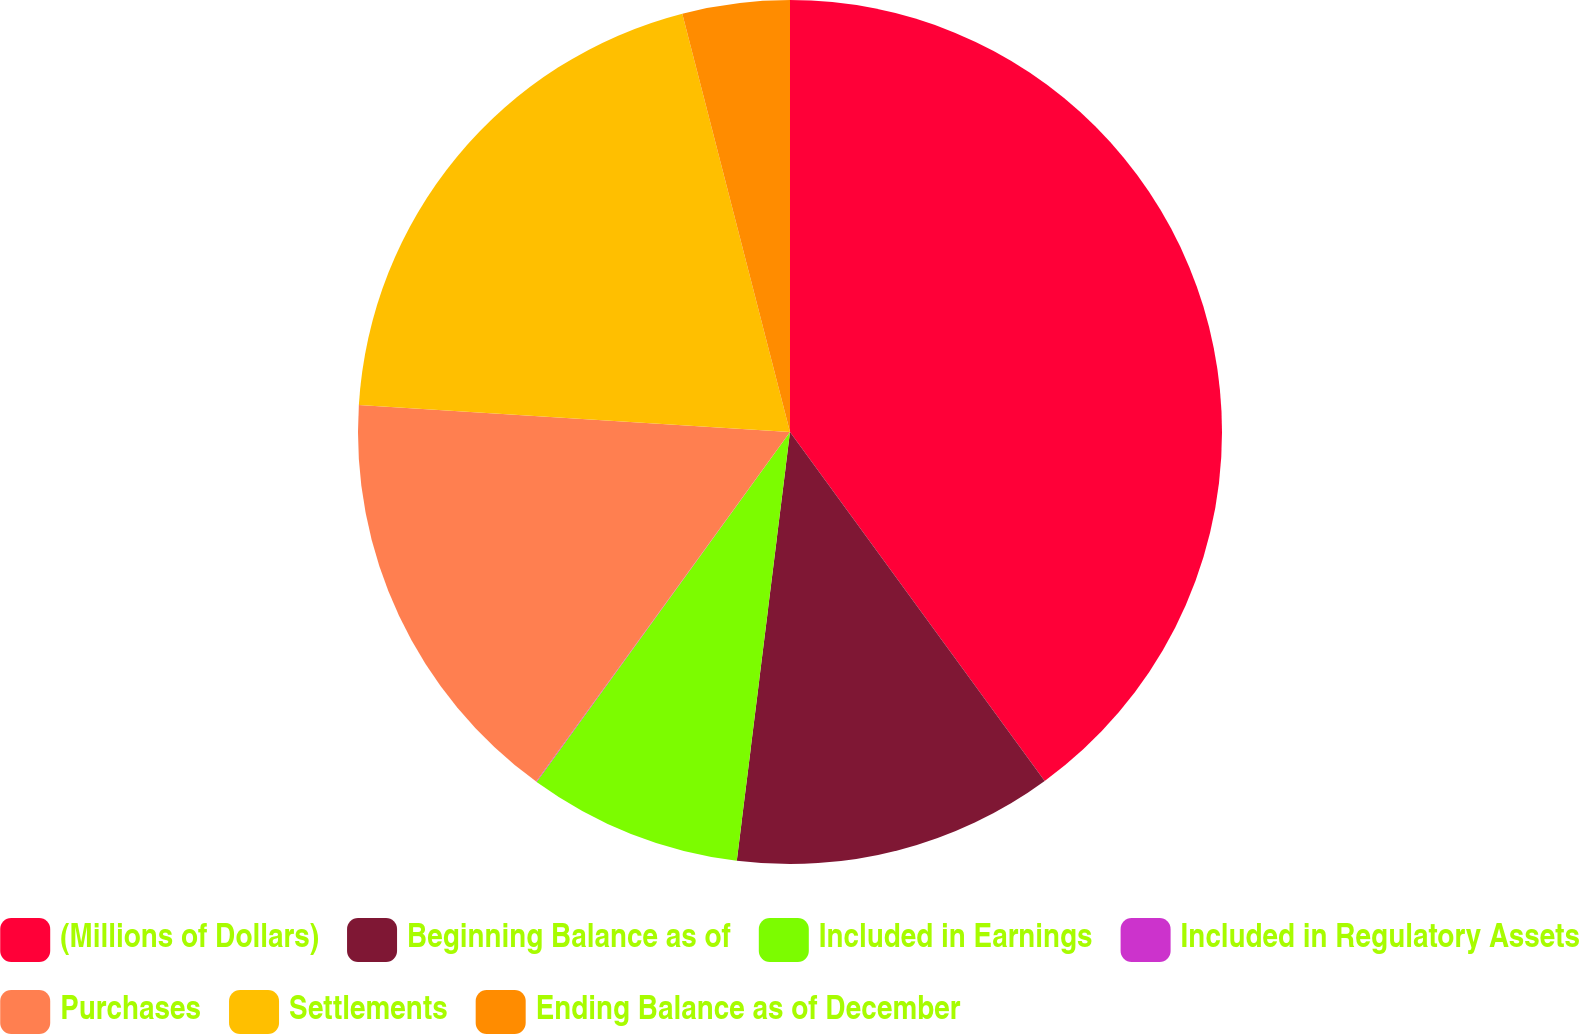<chart> <loc_0><loc_0><loc_500><loc_500><pie_chart><fcel>(Millions of Dollars)<fcel>Beginning Balance as of<fcel>Included in Earnings<fcel>Included in Regulatory Assets<fcel>Purchases<fcel>Settlements<fcel>Ending Balance as of December<nl><fcel>39.96%<fcel>12.0%<fcel>8.01%<fcel>0.02%<fcel>16.0%<fcel>19.99%<fcel>4.01%<nl></chart> 